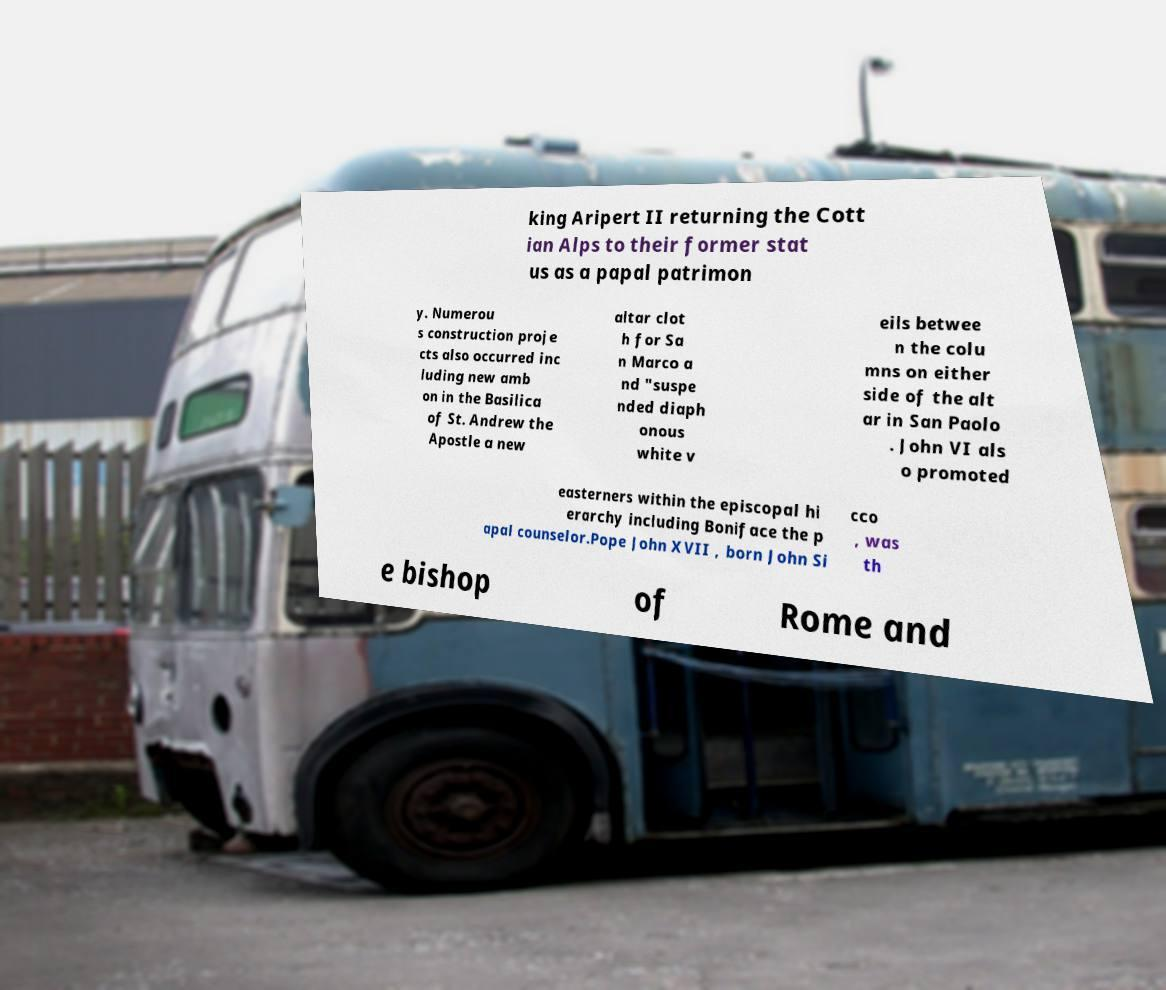Can you read and provide the text displayed in the image?This photo seems to have some interesting text. Can you extract and type it out for me? king Aripert II returning the Cott ian Alps to their former stat us as a papal patrimon y. Numerou s construction proje cts also occurred inc luding new amb on in the Basilica of St. Andrew the Apostle a new altar clot h for Sa n Marco a nd "suspe nded diaph onous white v eils betwee n the colu mns on either side of the alt ar in San Paolo . John VI als o promoted easterners within the episcopal hi erarchy including Boniface the p apal counselor.Pope John XVII , born John Si cco , was th e bishop of Rome and 